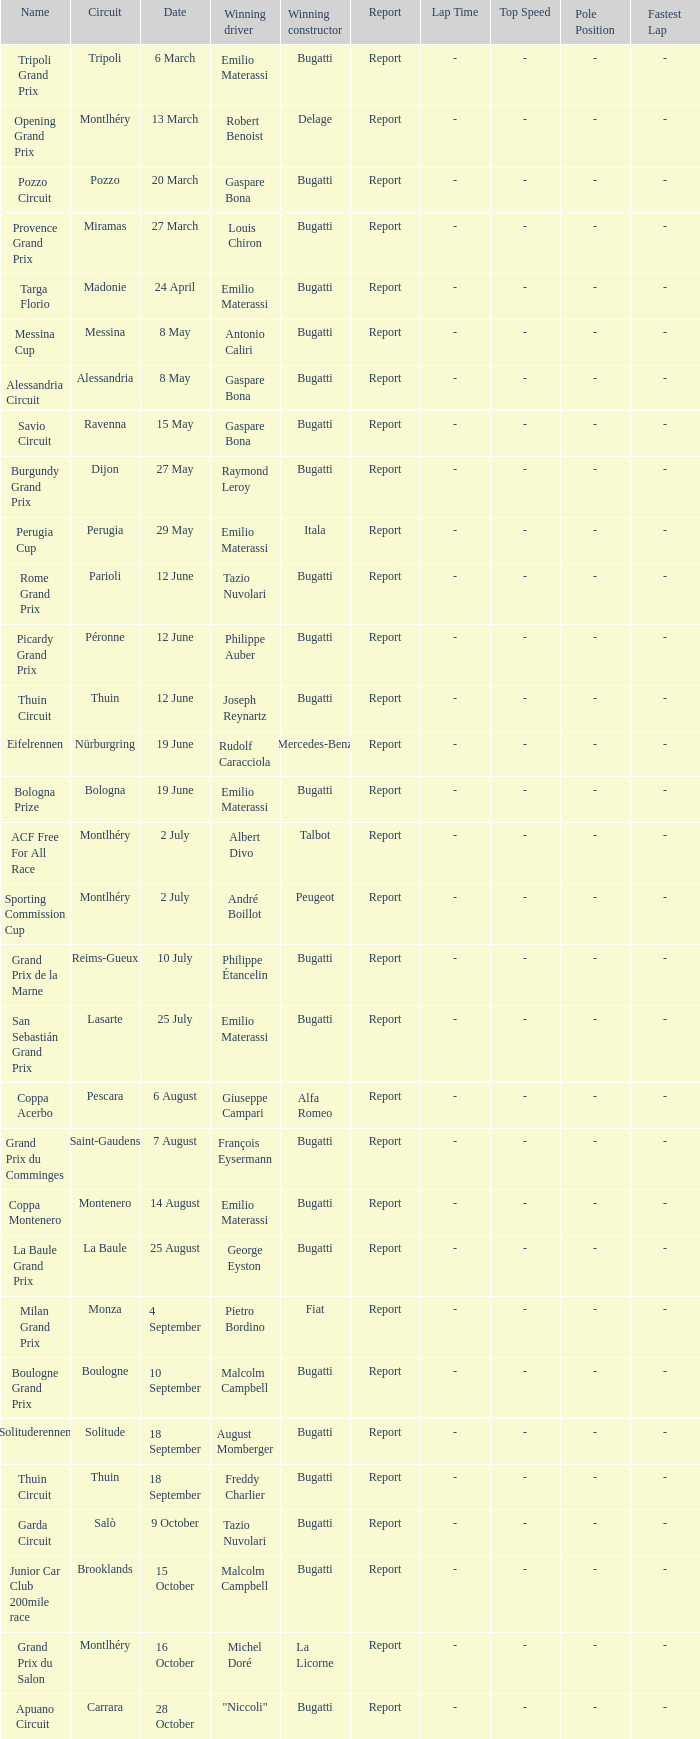Which circuit did françois eysermann win ? Saint-Gaudens. 